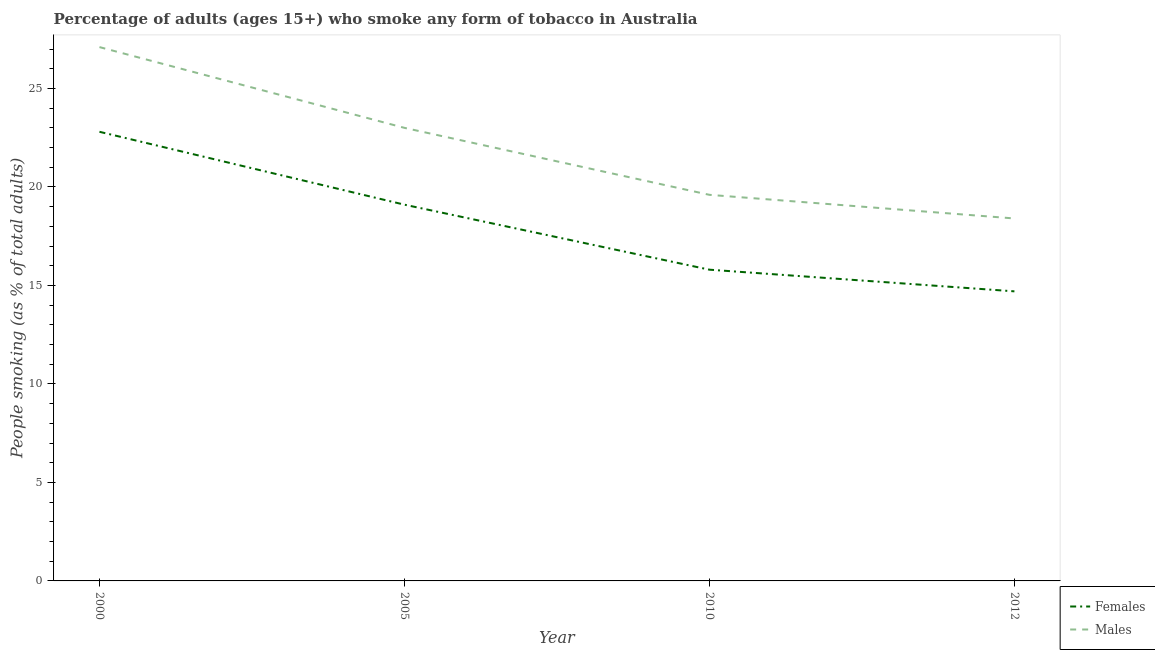How many different coloured lines are there?
Offer a very short reply. 2. Is the number of lines equal to the number of legend labels?
Your answer should be compact. Yes. What is the percentage of females who smoke in 2005?
Your response must be concise. 19.1. Across all years, what is the maximum percentage of males who smoke?
Your response must be concise. 27.1. In which year was the percentage of females who smoke maximum?
Your answer should be very brief. 2000. In which year was the percentage of males who smoke minimum?
Make the answer very short. 2012. What is the total percentage of females who smoke in the graph?
Provide a short and direct response. 72.4. What is the difference between the percentage of females who smoke in 2005 and that in 2010?
Provide a short and direct response. 3.3. What is the difference between the percentage of males who smoke in 2010 and the percentage of females who smoke in 2000?
Keep it short and to the point. -3.2. What is the average percentage of males who smoke per year?
Offer a very short reply. 22.02. In the year 2010, what is the difference between the percentage of males who smoke and percentage of females who smoke?
Offer a very short reply. 3.8. What is the ratio of the percentage of males who smoke in 2010 to that in 2012?
Give a very brief answer. 1.07. Is the percentage of males who smoke in 2005 less than that in 2010?
Your response must be concise. No. Is the difference between the percentage of males who smoke in 2000 and 2010 greater than the difference between the percentage of females who smoke in 2000 and 2010?
Ensure brevity in your answer.  Yes. What is the difference between the highest and the second highest percentage of males who smoke?
Offer a terse response. 4.1. What is the difference between the highest and the lowest percentage of females who smoke?
Keep it short and to the point. 8.1. Is the percentage of males who smoke strictly less than the percentage of females who smoke over the years?
Provide a short and direct response. No. How many lines are there?
Ensure brevity in your answer.  2. How many years are there in the graph?
Offer a very short reply. 4. What is the difference between two consecutive major ticks on the Y-axis?
Give a very brief answer. 5. Does the graph contain any zero values?
Your answer should be compact. No. What is the title of the graph?
Ensure brevity in your answer.  Percentage of adults (ages 15+) who smoke any form of tobacco in Australia. Does "Working only" appear as one of the legend labels in the graph?
Your answer should be compact. No. What is the label or title of the Y-axis?
Provide a short and direct response. People smoking (as % of total adults). What is the People smoking (as % of total adults) of Females in 2000?
Offer a very short reply. 22.8. What is the People smoking (as % of total adults) in Males in 2000?
Provide a succinct answer. 27.1. What is the People smoking (as % of total adults) of Males in 2005?
Your answer should be very brief. 23. What is the People smoking (as % of total adults) of Males in 2010?
Your answer should be compact. 19.6. What is the People smoking (as % of total adults) in Males in 2012?
Ensure brevity in your answer.  18.4. Across all years, what is the maximum People smoking (as % of total adults) in Females?
Ensure brevity in your answer.  22.8. Across all years, what is the maximum People smoking (as % of total adults) of Males?
Your answer should be very brief. 27.1. Across all years, what is the minimum People smoking (as % of total adults) in Females?
Ensure brevity in your answer.  14.7. Across all years, what is the minimum People smoking (as % of total adults) of Males?
Keep it short and to the point. 18.4. What is the total People smoking (as % of total adults) of Females in the graph?
Give a very brief answer. 72.4. What is the total People smoking (as % of total adults) in Males in the graph?
Make the answer very short. 88.1. What is the difference between the People smoking (as % of total adults) of Females in 2000 and that in 2010?
Ensure brevity in your answer.  7. What is the difference between the People smoking (as % of total adults) in Males in 2000 and that in 2012?
Keep it short and to the point. 8.7. What is the difference between the People smoking (as % of total adults) in Males in 2005 and that in 2012?
Give a very brief answer. 4.6. What is the difference between the People smoking (as % of total adults) in Females in 2000 and the People smoking (as % of total adults) in Males in 2012?
Give a very brief answer. 4.4. What is the difference between the People smoking (as % of total adults) of Females in 2005 and the People smoking (as % of total adults) of Males in 2010?
Offer a terse response. -0.5. What is the difference between the People smoking (as % of total adults) in Females in 2005 and the People smoking (as % of total adults) in Males in 2012?
Keep it short and to the point. 0.7. What is the average People smoking (as % of total adults) of Females per year?
Keep it short and to the point. 18.1. What is the average People smoking (as % of total adults) in Males per year?
Offer a very short reply. 22.02. In the year 2000, what is the difference between the People smoking (as % of total adults) of Females and People smoking (as % of total adults) of Males?
Keep it short and to the point. -4.3. In the year 2010, what is the difference between the People smoking (as % of total adults) in Females and People smoking (as % of total adults) in Males?
Make the answer very short. -3.8. What is the ratio of the People smoking (as % of total adults) in Females in 2000 to that in 2005?
Offer a very short reply. 1.19. What is the ratio of the People smoking (as % of total adults) of Males in 2000 to that in 2005?
Provide a succinct answer. 1.18. What is the ratio of the People smoking (as % of total adults) of Females in 2000 to that in 2010?
Provide a short and direct response. 1.44. What is the ratio of the People smoking (as % of total adults) in Males in 2000 to that in 2010?
Provide a succinct answer. 1.38. What is the ratio of the People smoking (as % of total adults) of Females in 2000 to that in 2012?
Offer a very short reply. 1.55. What is the ratio of the People smoking (as % of total adults) of Males in 2000 to that in 2012?
Give a very brief answer. 1.47. What is the ratio of the People smoking (as % of total adults) of Females in 2005 to that in 2010?
Provide a short and direct response. 1.21. What is the ratio of the People smoking (as % of total adults) in Males in 2005 to that in 2010?
Make the answer very short. 1.17. What is the ratio of the People smoking (as % of total adults) of Females in 2005 to that in 2012?
Make the answer very short. 1.3. What is the ratio of the People smoking (as % of total adults) in Males in 2005 to that in 2012?
Make the answer very short. 1.25. What is the ratio of the People smoking (as % of total adults) in Females in 2010 to that in 2012?
Make the answer very short. 1.07. What is the ratio of the People smoking (as % of total adults) in Males in 2010 to that in 2012?
Your answer should be compact. 1.07. What is the difference between the highest and the second highest People smoking (as % of total adults) in Females?
Your answer should be compact. 3.7. What is the difference between the highest and the second highest People smoking (as % of total adults) in Males?
Your answer should be compact. 4.1. What is the difference between the highest and the lowest People smoking (as % of total adults) of Females?
Provide a succinct answer. 8.1. What is the difference between the highest and the lowest People smoking (as % of total adults) of Males?
Your answer should be compact. 8.7. 